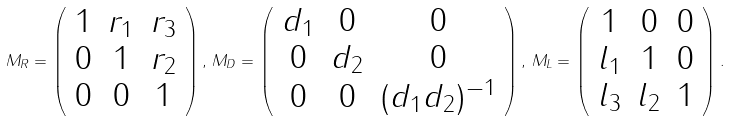Convert formula to latex. <formula><loc_0><loc_0><loc_500><loc_500>M _ { R } = \left ( \begin{array} { c c c } 1 & r _ { 1 } & r _ { 3 } \\ 0 & 1 & r _ { 2 } \\ 0 & 0 & 1 \\ \end{array} \right ) , \, M _ { D } = \left ( \begin{array} { c c c } d _ { 1 } & 0 & 0 \\ 0 & d _ { 2 } & 0 \\ 0 & 0 & ( d _ { 1 } d _ { 2 } ) ^ { - 1 } \\ \end{array} \right ) , \, M _ { L } = \left ( \begin{array} { c c c } 1 & 0 & 0 \\ l _ { 1 } & 1 & 0 \\ l _ { 3 } & l _ { 2 } & 1 \\ \end{array} \right ) .</formula> 